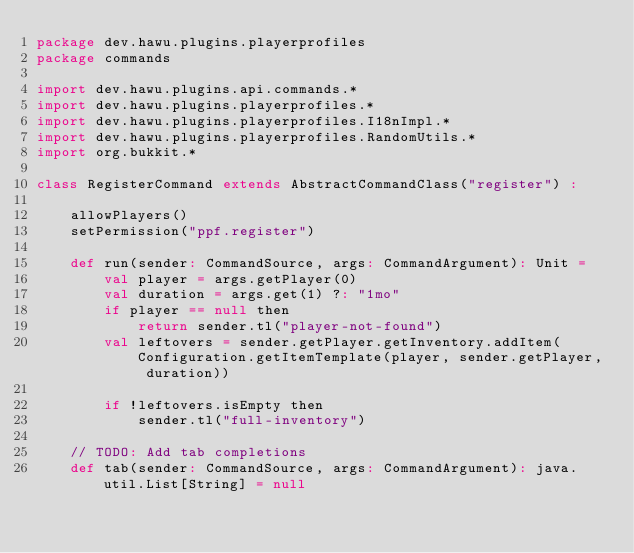Convert code to text. <code><loc_0><loc_0><loc_500><loc_500><_Scala_>package dev.hawu.plugins.playerprofiles
package commands

import dev.hawu.plugins.api.commands.*
import dev.hawu.plugins.playerprofiles.*
import dev.hawu.plugins.playerprofiles.I18nImpl.*
import dev.hawu.plugins.playerprofiles.RandomUtils.*
import org.bukkit.*

class RegisterCommand extends AbstractCommandClass("register") :

    allowPlayers()
    setPermission("ppf.register")

    def run(sender: CommandSource, args: CommandArgument): Unit =
        val player = args.getPlayer(0)
        val duration = args.get(1) ?: "1mo"
        if player == null then
            return sender.tl("player-not-found")
        val leftovers = sender.getPlayer.getInventory.addItem(Configuration.getItemTemplate(player, sender.getPlayer, duration))

        if !leftovers.isEmpty then
            sender.tl("full-inventory")

    // TODO: Add tab completions
    def tab(sender: CommandSource, args: CommandArgument): java.util.List[String] = null
</code> 